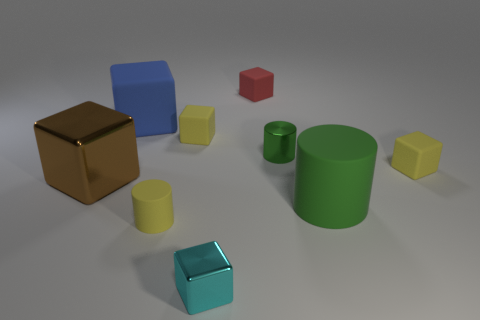Subtract 3 cubes. How many cubes are left? 3 Subtract all brown cubes. How many cubes are left? 5 Subtract all cyan blocks. How many blocks are left? 5 Subtract all purple blocks. Subtract all green cylinders. How many blocks are left? 6 Subtract all cylinders. How many objects are left? 6 Add 9 red metal cubes. How many red metal cubes exist? 9 Subtract 0 cyan cylinders. How many objects are left? 9 Subtract all gray cubes. Subtract all big blocks. How many objects are left? 7 Add 2 small yellow cylinders. How many small yellow cylinders are left? 3 